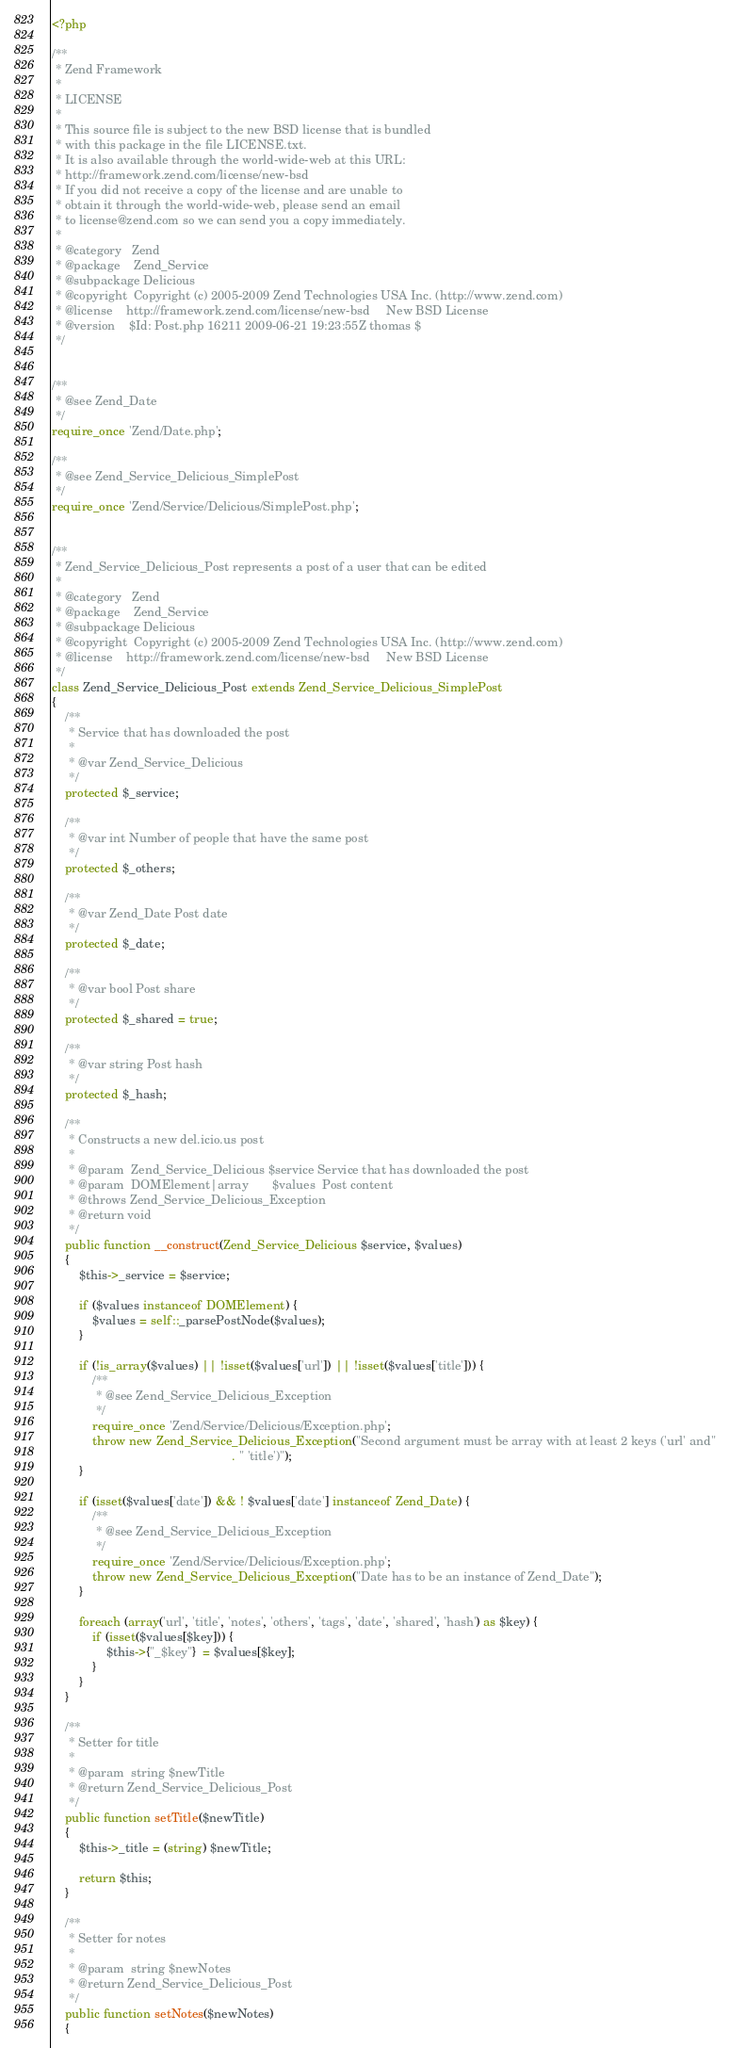<code> <loc_0><loc_0><loc_500><loc_500><_PHP_><?php

/**
 * Zend Framework
 *
 * LICENSE
 *
 * This source file is subject to the new BSD license that is bundled
 * with this package in the file LICENSE.txt.
 * It is also available through the world-wide-web at this URL:
 * http://framework.zend.com/license/new-bsd
 * If you did not receive a copy of the license and are unable to
 * obtain it through the world-wide-web, please send an email
 * to license@zend.com so we can send you a copy immediately.
 *
 * @category   Zend
 * @package    Zend_Service
 * @subpackage Delicious
 * @copyright  Copyright (c) 2005-2009 Zend Technologies USA Inc. (http://www.zend.com)
 * @license    http://framework.zend.com/license/new-bsd     New BSD License
 * @version    $Id: Post.php 16211 2009-06-21 19:23:55Z thomas $
 */


/**
 * @see Zend_Date
 */
require_once 'Zend/Date.php';

/**
 * @see Zend_Service_Delicious_SimplePost
 */
require_once 'Zend/Service/Delicious/SimplePost.php';


/**
 * Zend_Service_Delicious_Post represents a post of a user that can be edited
 *
 * @category   Zend
 * @package    Zend_Service
 * @subpackage Delicious
 * @copyright  Copyright (c) 2005-2009 Zend Technologies USA Inc. (http://www.zend.com)
 * @license    http://framework.zend.com/license/new-bsd     New BSD License
 */
class Zend_Service_Delicious_Post extends Zend_Service_Delicious_SimplePost
{
    /**
     * Service that has downloaded the post
     *
     * @var Zend_Service_Delicious
     */
    protected $_service;

    /**
     * @var int Number of people that have the same post
     */
    protected $_others;

    /**
     * @var Zend_Date Post date
     */
    protected $_date;

    /**
     * @var bool Post share
     */
    protected $_shared = true;

    /**
     * @var string Post hash
     */
    protected $_hash;

    /**
     * Constructs a new del.icio.us post
     *
     * @param  Zend_Service_Delicious $service Service that has downloaded the post
     * @param  DOMElement|array       $values  Post content
     * @throws Zend_Service_Delicious_Exception
     * @return void
     */
    public function __construct(Zend_Service_Delicious $service, $values)
    {
        $this->_service = $service;

        if ($values instanceof DOMElement) {
            $values = self::_parsePostNode($values);
        }

        if (!is_array($values) || !isset($values['url']) || !isset($values['title'])) {
            /**
             * @see Zend_Service_Delicious_Exception
             */
            require_once 'Zend/Service/Delicious/Exception.php';
            throw new Zend_Service_Delicious_Exception("Second argument must be array with at least 2 keys ('url' and"
                                                     . " 'title')");
        }

        if (isset($values['date']) && ! $values['date'] instanceof Zend_Date) {
            /**
             * @see Zend_Service_Delicious_Exception
             */
            require_once 'Zend/Service/Delicious/Exception.php';
            throw new Zend_Service_Delicious_Exception("Date has to be an instance of Zend_Date");
        }

        foreach (array('url', 'title', 'notes', 'others', 'tags', 'date', 'shared', 'hash') as $key) {
            if (isset($values[$key])) {
                $this->{"_$key"}  = $values[$key];
            }
        }
    }

    /**
     * Setter for title
     *
     * @param  string $newTitle
     * @return Zend_Service_Delicious_Post
     */
    public function setTitle($newTitle)
    {
        $this->_title = (string) $newTitle;

        return $this;
    }

    /**
     * Setter for notes
     *
     * @param  string $newNotes
     * @return Zend_Service_Delicious_Post
     */
    public function setNotes($newNotes)
    {</code> 